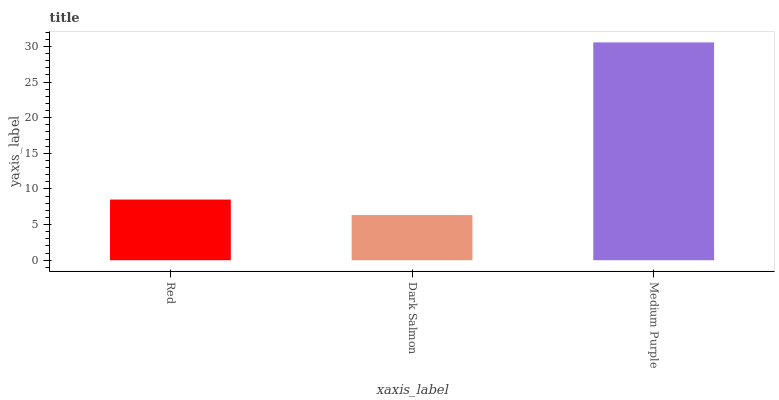Is Dark Salmon the minimum?
Answer yes or no. Yes. Is Medium Purple the maximum?
Answer yes or no. Yes. Is Medium Purple the minimum?
Answer yes or no. No. Is Dark Salmon the maximum?
Answer yes or no. No. Is Medium Purple greater than Dark Salmon?
Answer yes or no. Yes. Is Dark Salmon less than Medium Purple?
Answer yes or no. Yes. Is Dark Salmon greater than Medium Purple?
Answer yes or no. No. Is Medium Purple less than Dark Salmon?
Answer yes or no. No. Is Red the high median?
Answer yes or no. Yes. Is Red the low median?
Answer yes or no. Yes. Is Dark Salmon the high median?
Answer yes or no. No. Is Dark Salmon the low median?
Answer yes or no. No. 